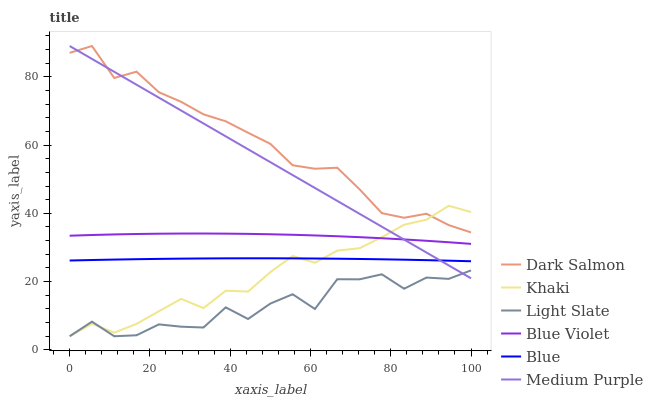Does Light Slate have the minimum area under the curve?
Answer yes or no. Yes. Does Dark Salmon have the maximum area under the curve?
Answer yes or no. Yes. Does Khaki have the minimum area under the curve?
Answer yes or no. No. Does Khaki have the maximum area under the curve?
Answer yes or no. No. Is Medium Purple the smoothest?
Answer yes or no. Yes. Is Light Slate the roughest?
Answer yes or no. Yes. Is Khaki the smoothest?
Answer yes or no. No. Is Khaki the roughest?
Answer yes or no. No. Does Khaki have the lowest value?
Answer yes or no. Yes. Does Dark Salmon have the lowest value?
Answer yes or no. No. Does Medium Purple have the highest value?
Answer yes or no. Yes. Does Khaki have the highest value?
Answer yes or no. No. Is Blue Violet less than Dark Salmon?
Answer yes or no. Yes. Is Dark Salmon greater than Blue Violet?
Answer yes or no. Yes. Does Blue Violet intersect Khaki?
Answer yes or no. Yes. Is Blue Violet less than Khaki?
Answer yes or no. No. Is Blue Violet greater than Khaki?
Answer yes or no. No. Does Blue Violet intersect Dark Salmon?
Answer yes or no. No. 